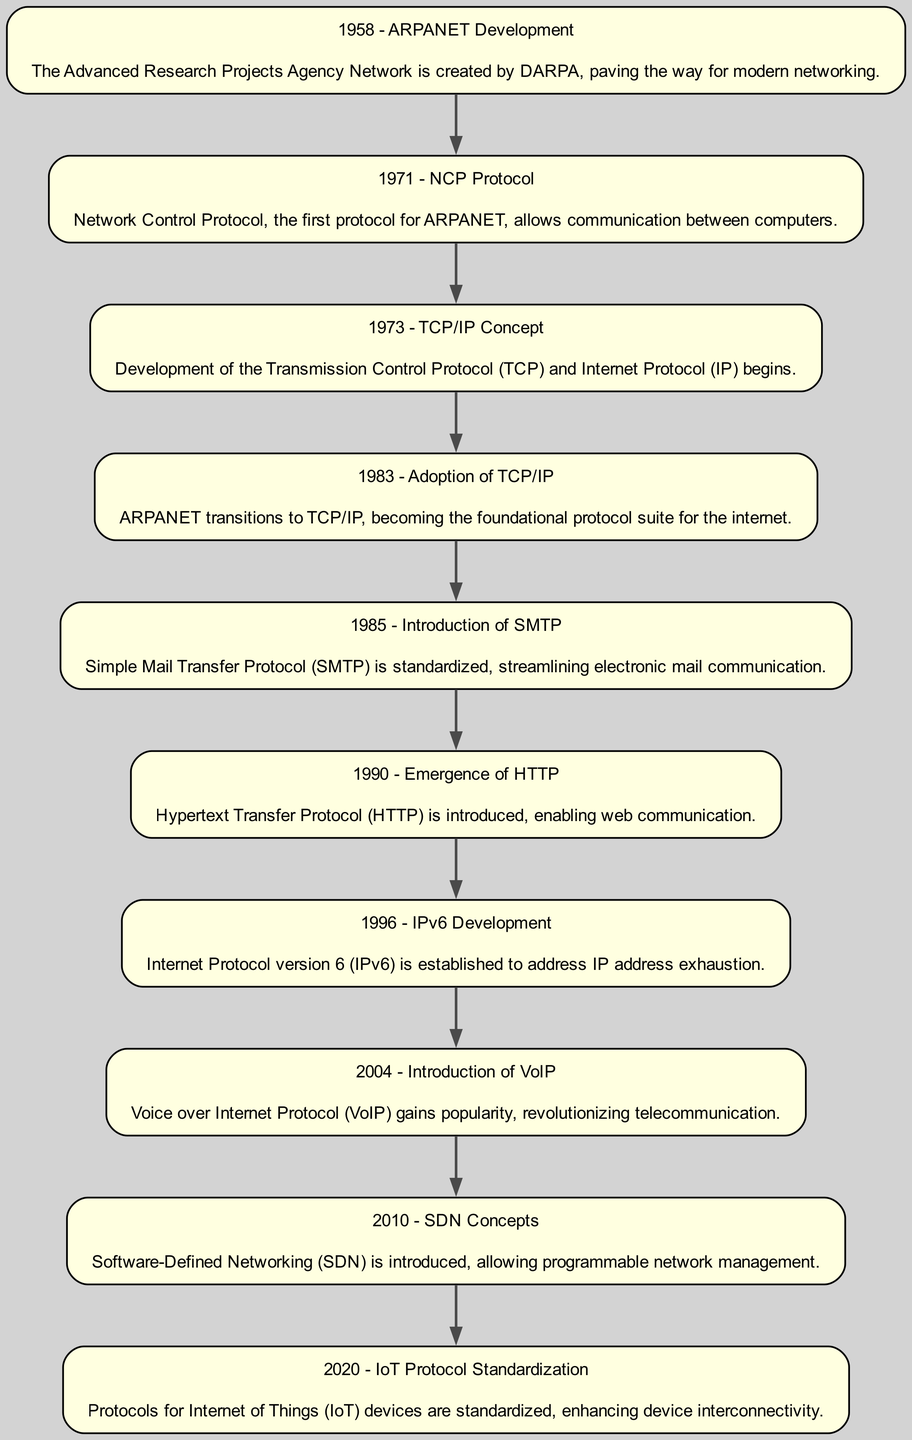What year was ARPANET developed? The diagram indicates that ARPANET was developed in 1958. This is illustrated as the first element in the flow chart, signifying its foundational role in networking technology.
Answer: 1958 How many protocols are introduced after TCP/IP? The flow chart contains three nodes following the adoption of TCP/IP in 1983: the introduction of SMTP in 1985, the emergence of HTTP in 1990, and the development of IPv6 in 1996.
Answer: 3 Which protocol is established in 1996? The diagram specifies that Internet Protocol version 6 (IPv6) is developed in 1996, as indicated in the respective node.
Answer: IPv6 What is the main technology introduced in 2010? According to the flow chart, the main technology introduced in 2010 is Software-Defined Networking (SDN), which is explicitly stated in that node.
Answer: Software-Defined Networking Which protocol revolutionized telecommunications in 2004? Based on the diagram, Voice over Internet Protocol (VoIP) gained popularity in 2004 and is described as revolutionary for telecommunications.
Answer: VoIP What was the first protocol for ARPANET? The Node labeled 1971 discusses Network Control Protocol (NCP), which served as the first protocol for ARPANET. This can be deduced from the sequence of developments shown in the diagram.
Answer: NCP Which protocol was standardized to improve email communication? The flow chart highlights Simple Mail Transfer Protocol (SMTP), introduced in 1985, as the standardized protocol that streamlined electronic mail communication.
Answer: SMTP What was the focus of the protocol standardization in 2020? The last node in the flow chart indicates that the focus in 2020 was on standardizing protocols for Internet of Things (IoT) devices, aimed at enhancing their interconnectivity.
Answer: IoT devices 